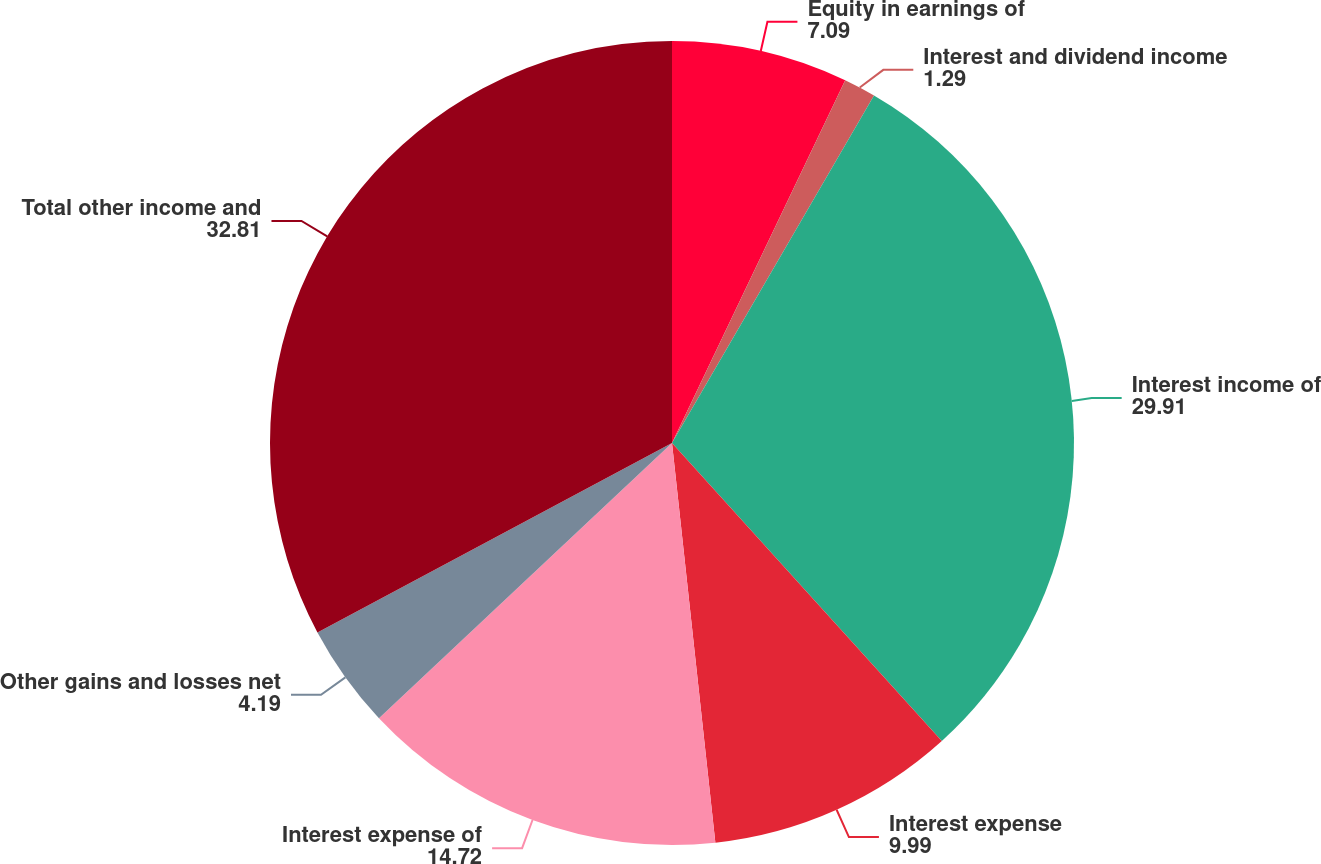Convert chart. <chart><loc_0><loc_0><loc_500><loc_500><pie_chart><fcel>Equity in earnings of<fcel>Interest and dividend income<fcel>Interest income of<fcel>Interest expense<fcel>Interest expense of<fcel>Other gains and losses net<fcel>Total other income and<nl><fcel>7.09%<fcel>1.29%<fcel>29.91%<fcel>9.99%<fcel>14.72%<fcel>4.19%<fcel>32.81%<nl></chart> 